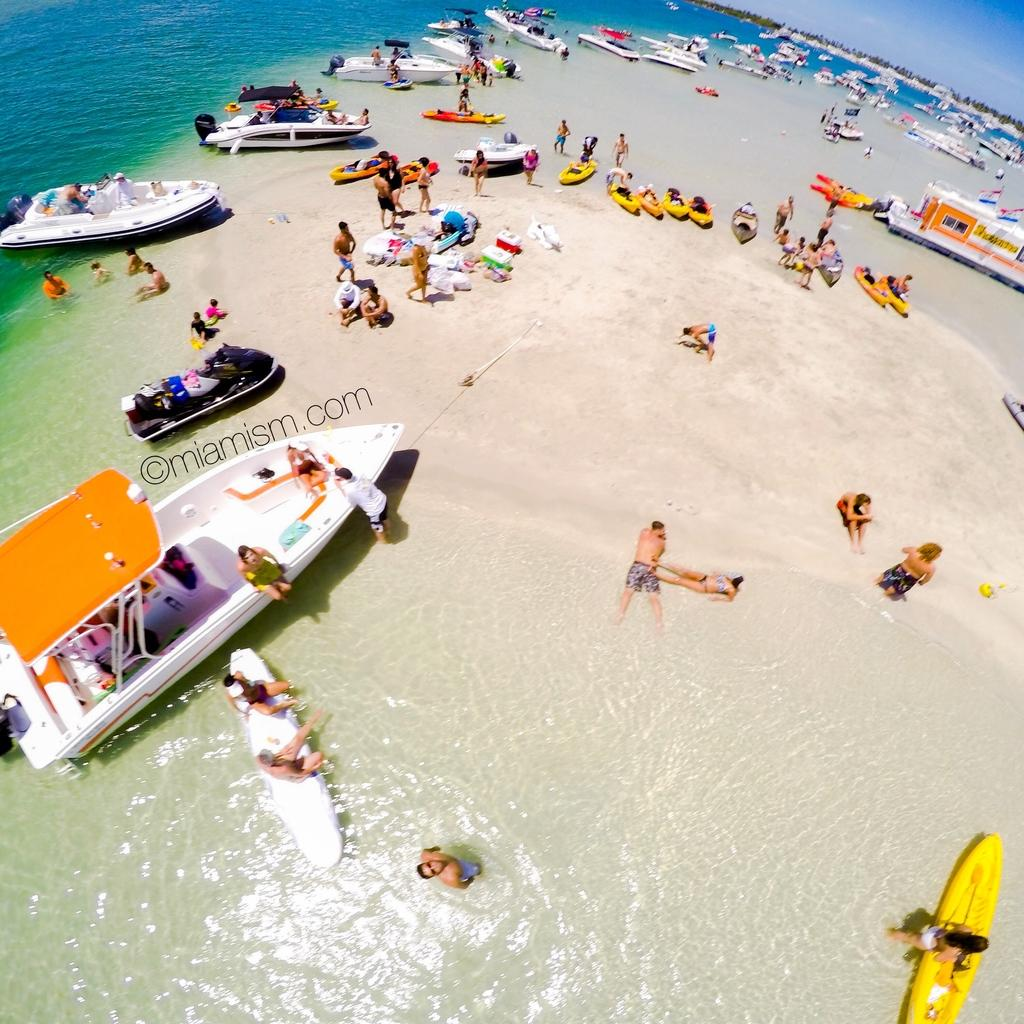What type of vehicles can be seen in the image? There are boats in the image. What can be seen on the shore in the image? There are people on the beach. What large body of water is visible in the image? There is an ocean visible in the image. What type of vegetation is in the background of the image? There are trees in the background of the image. What else is visible in the background of the image? The sky is visible in the background of the image. What type of advertisement can be seen on the beach in the image? There is no advertisement present on the beach in the image. What color is the hat worn by the person on the beach in the image? There is no hat visible on any person in the image. 